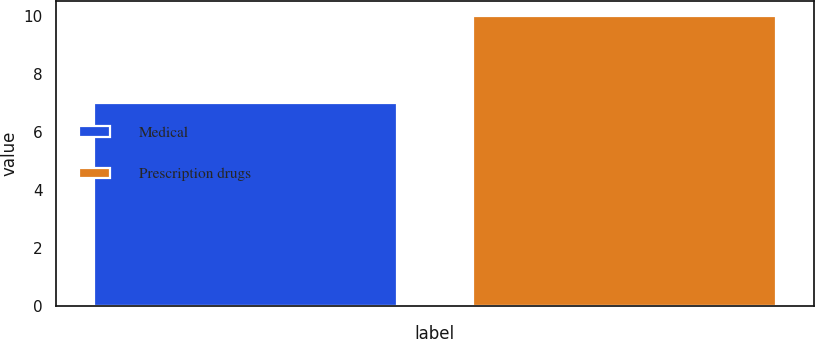Convert chart to OTSL. <chart><loc_0><loc_0><loc_500><loc_500><bar_chart><fcel>Medical<fcel>Prescription drugs<nl><fcel>7<fcel>10<nl></chart> 